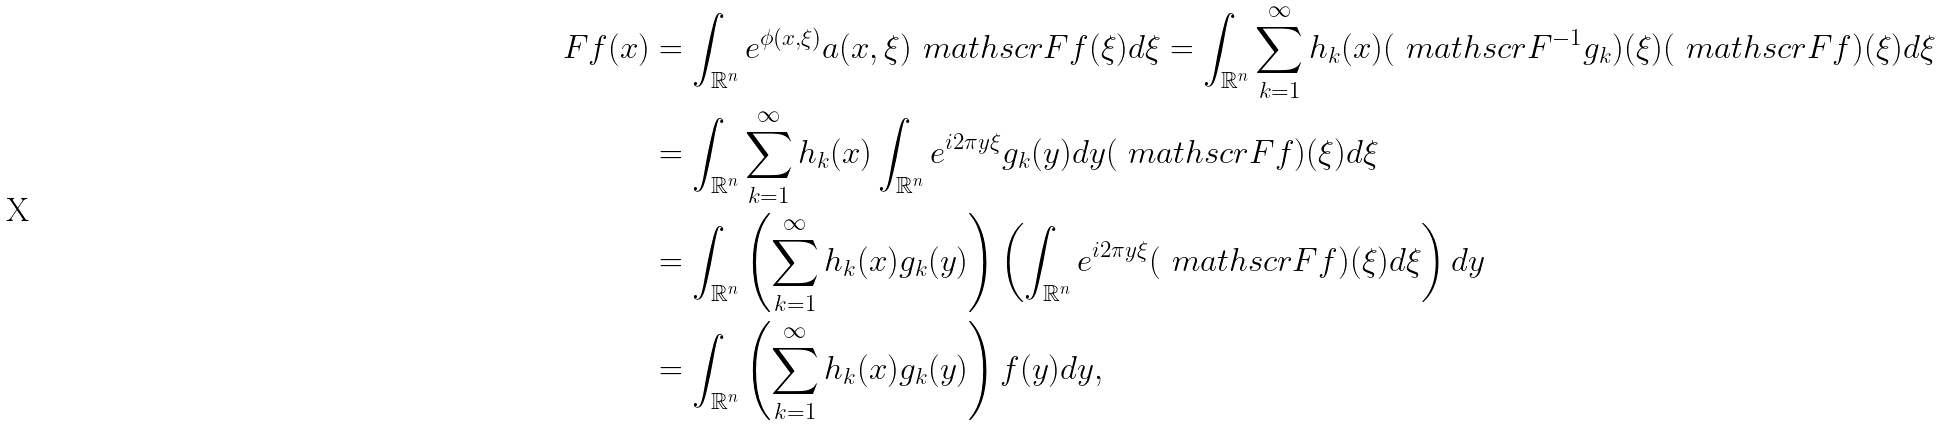<formula> <loc_0><loc_0><loc_500><loc_500>F f ( x ) & = \int _ { \mathbb { R } ^ { n } } e ^ { \phi ( x , \xi ) } a ( x , \xi ) \ m a t h s c r { F } f ( \xi ) d \xi = \int _ { \mathbb { R } ^ { n } } \sum _ { k = 1 } ^ { \infty } h _ { k } ( x ) ( \ m a t h s c r { F } ^ { - 1 } { g } _ { k } ) ( \xi ) ( \ m a t h s c r { F } { f } ) ( \xi ) d \xi \\ & = \int _ { \mathbb { R } ^ { n } } \sum _ { k = 1 } ^ { \infty } h _ { k } ( x ) \int _ { \mathbb { R } ^ { n } } e ^ { i 2 \pi y \xi } g _ { k } ( y ) d y ( \ m a t h s c r { F } { f } ) ( \xi ) d \xi \\ & = \int _ { \mathbb { R } ^ { n } } \left ( \sum _ { k = 1 } ^ { \infty } h _ { k } ( x ) g _ { k } ( y ) \right ) \left ( \int _ { \mathbb { R } ^ { n } } e ^ { i 2 \pi y \xi } ( \ m a t h s c r { F } { f } ) ( \xi ) d \xi \right ) d y \\ & = \int _ { \mathbb { R } ^ { n } } \left ( \sum _ { k = 1 } ^ { \infty } h _ { k } ( x ) g _ { k } ( y ) \right ) f ( y ) d y ,</formula> 